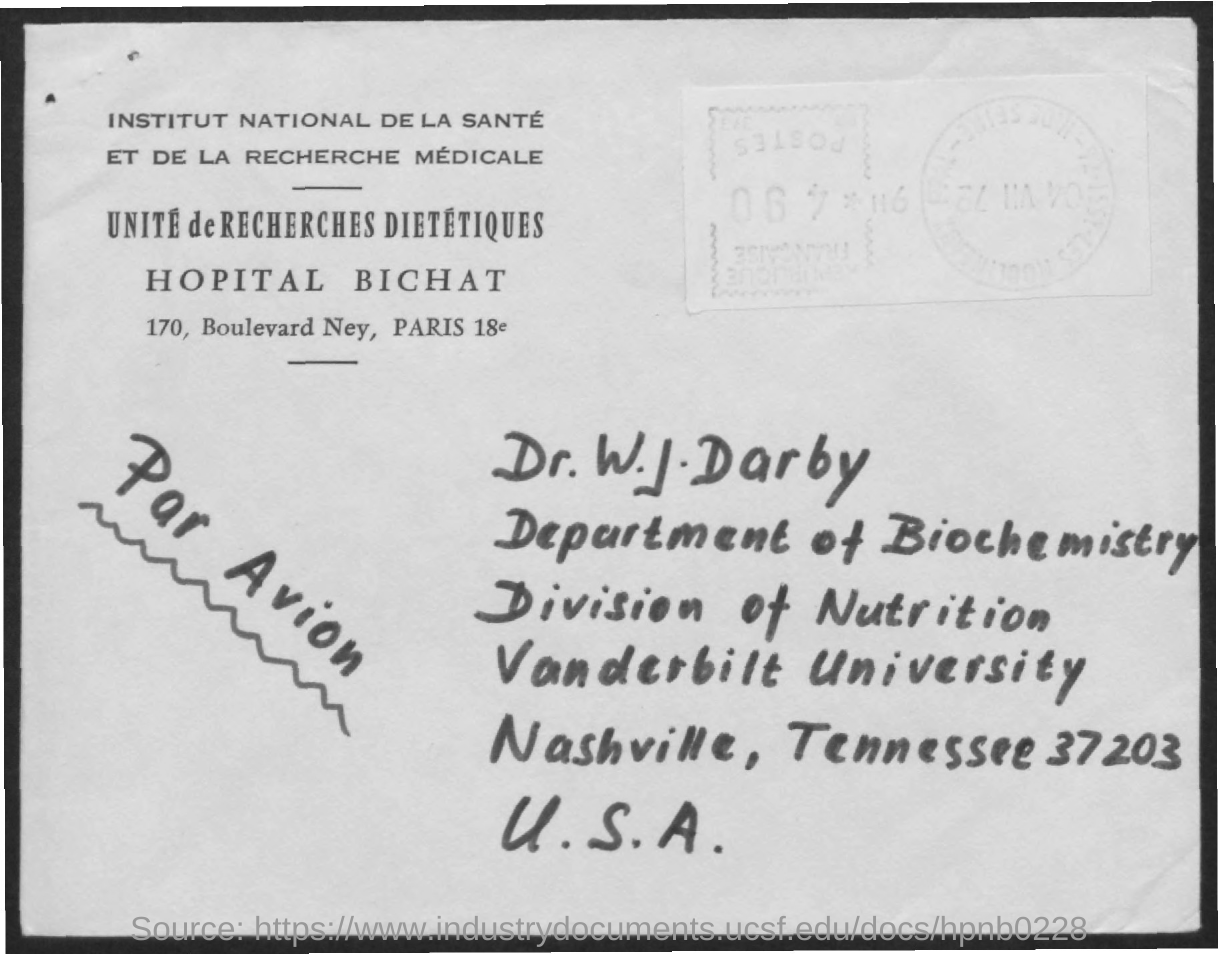Who is the addresse?
Keep it short and to the point. Dr. W. J. Darby. Which is the department mentioned in the address?
Provide a succinct answer. Department of Biochemistry. What is the division specified?
Offer a terse response. Division of Nutrition. Which is the University specified?
Give a very brief answer. Vanderbilt University. What is the zipcode specified?
Your response must be concise. 37203. 